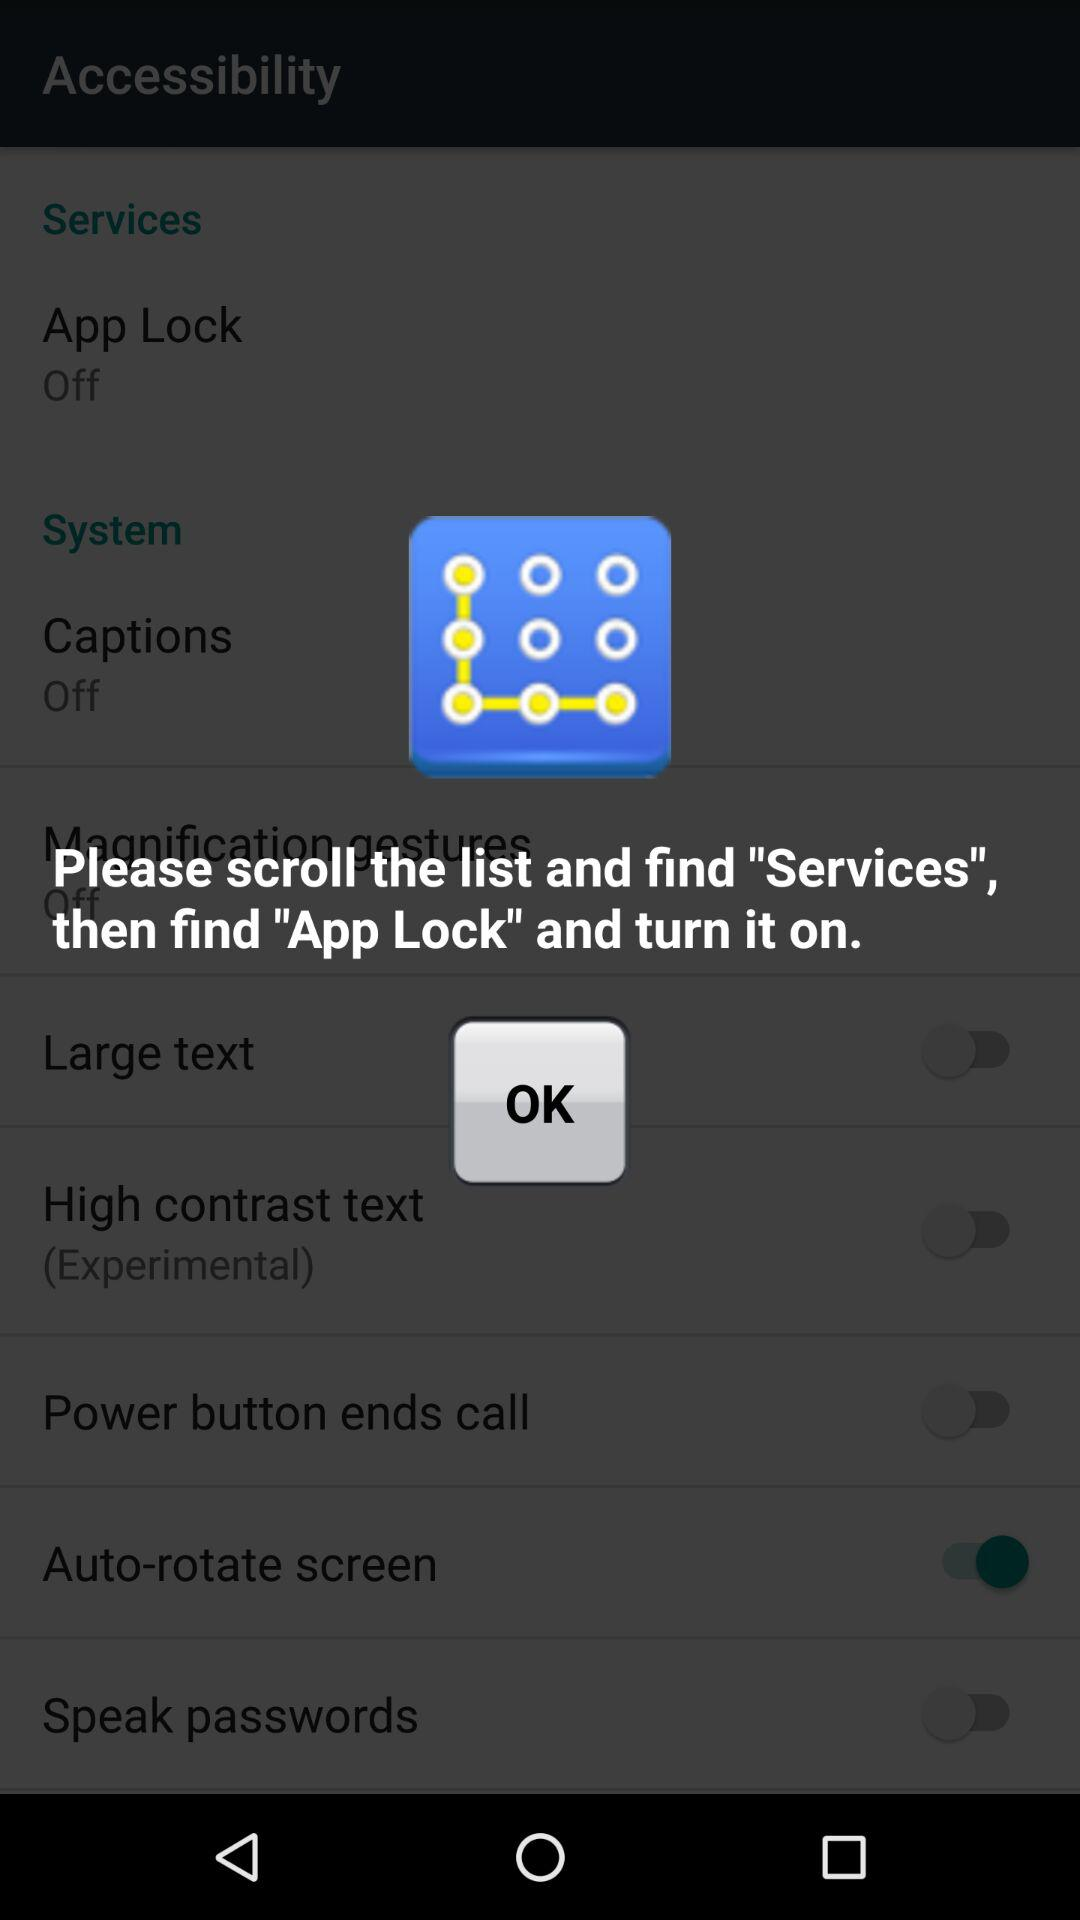How many switches are there on the screen?
Answer the question using a single word or phrase. 5 